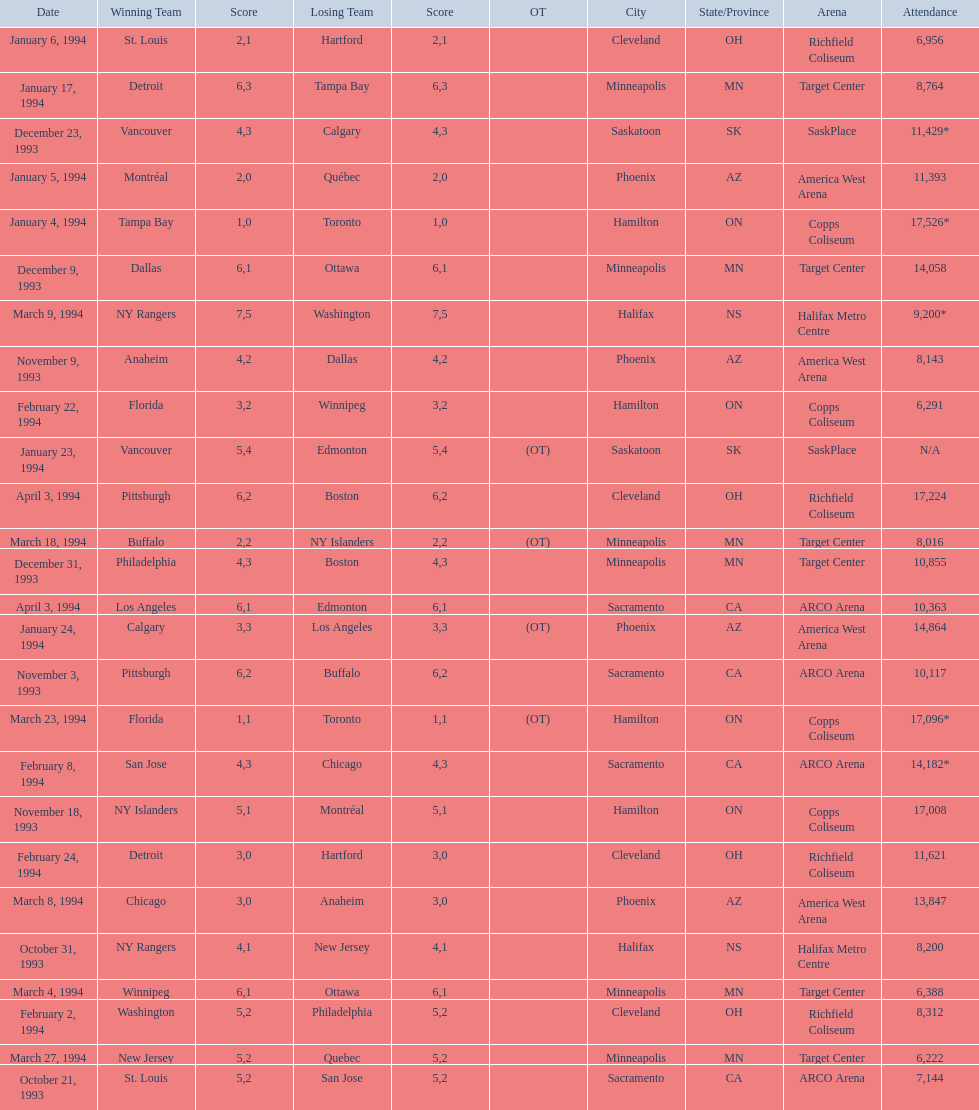How many more people attended the november 18, 1993 games than the november 9th game? 8865. 